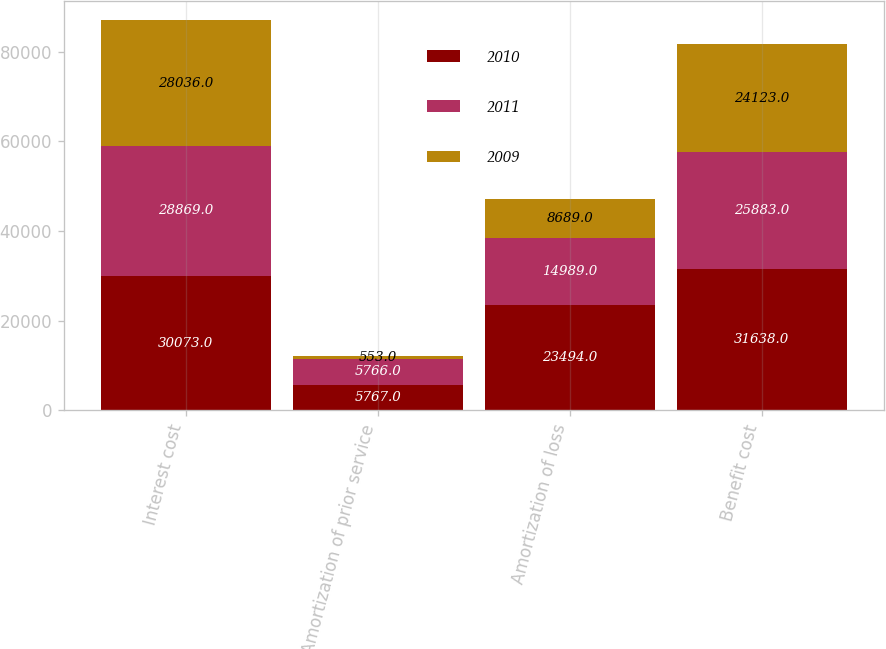Convert chart. <chart><loc_0><loc_0><loc_500><loc_500><stacked_bar_chart><ecel><fcel>Interest cost<fcel>Amortization of prior service<fcel>Amortization of loss<fcel>Benefit cost<nl><fcel>2010<fcel>30073<fcel>5767<fcel>23494<fcel>31638<nl><fcel>2011<fcel>28869<fcel>5766<fcel>14989<fcel>25883<nl><fcel>2009<fcel>28036<fcel>553<fcel>8689<fcel>24123<nl></chart> 